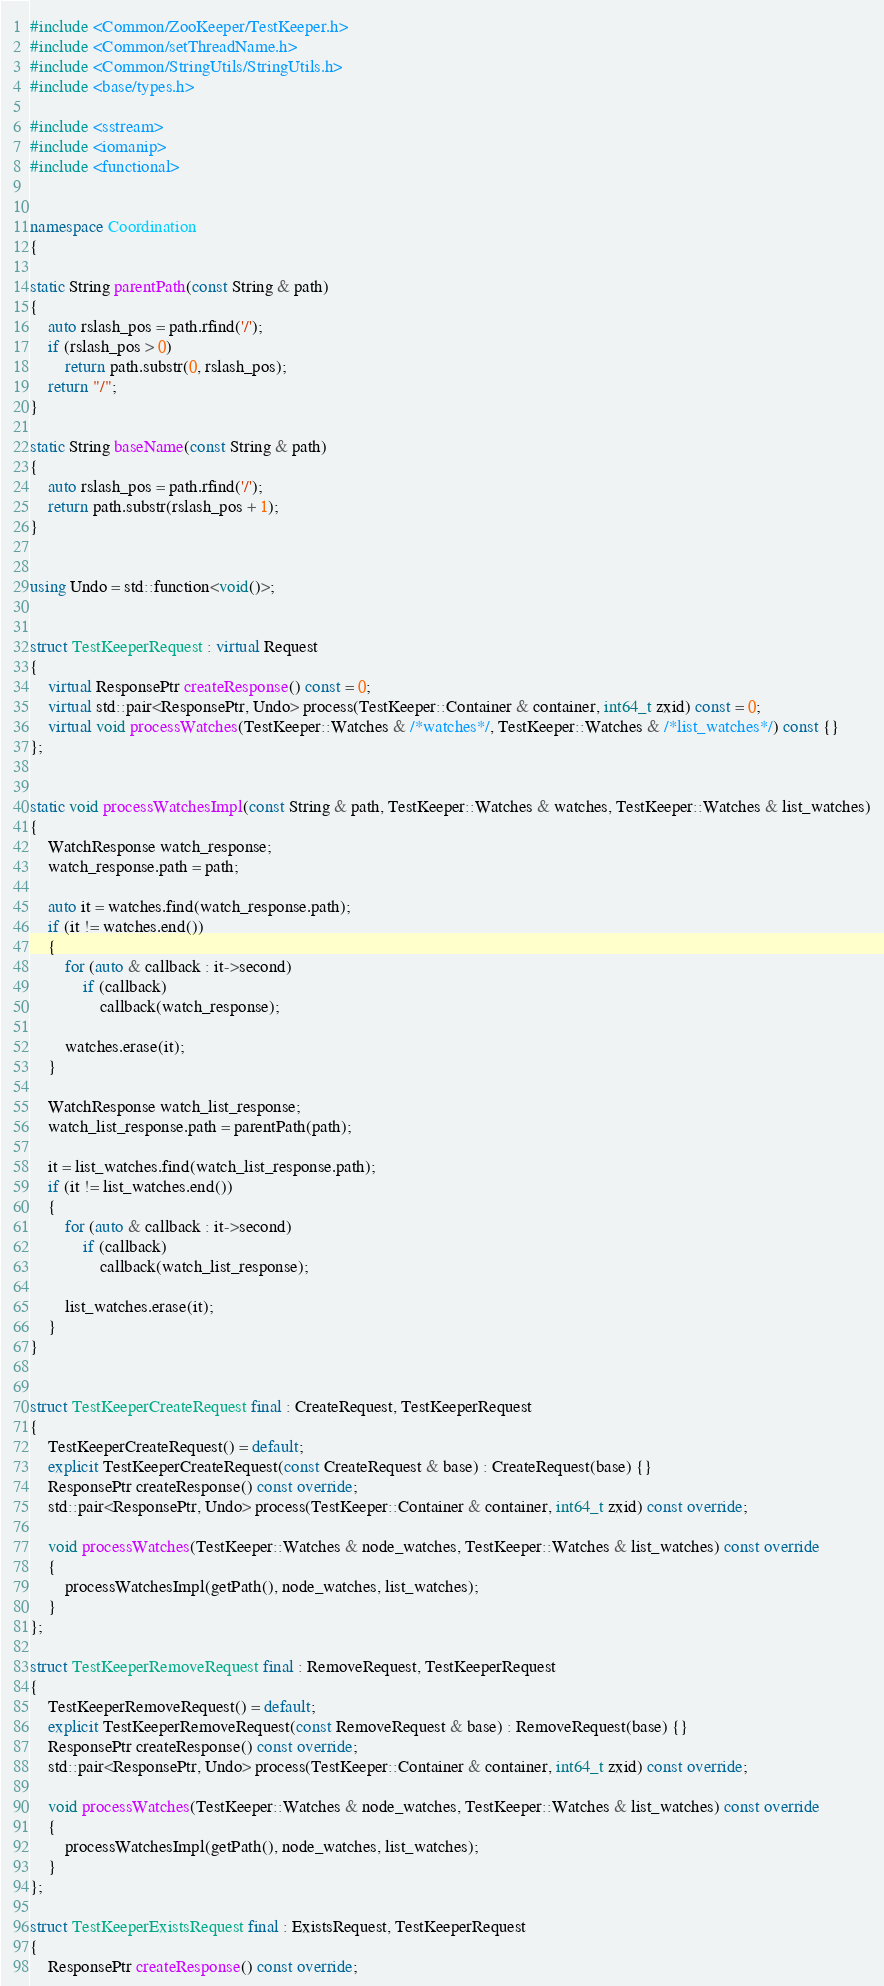<code> <loc_0><loc_0><loc_500><loc_500><_C++_>#include <Common/ZooKeeper/TestKeeper.h>
#include <Common/setThreadName.h>
#include <Common/StringUtils/StringUtils.h>
#include <base/types.h>

#include <sstream>
#include <iomanip>
#include <functional>


namespace Coordination
{

static String parentPath(const String & path)
{
    auto rslash_pos = path.rfind('/');
    if (rslash_pos > 0)
        return path.substr(0, rslash_pos);
    return "/";
}

static String baseName(const String & path)
{
    auto rslash_pos = path.rfind('/');
    return path.substr(rslash_pos + 1);
}


using Undo = std::function<void()>;


struct TestKeeperRequest : virtual Request
{
    virtual ResponsePtr createResponse() const = 0;
    virtual std::pair<ResponsePtr, Undo> process(TestKeeper::Container & container, int64_t zxid) const = 0;
    virtual void processWatches(TestKeeper::Watches & /*watches*/, TestKeeper::Watches & /*list_watches*/) const {}
};


static void processWatchesImpl(const String & path, TestKeeper::Watches & watches, TestKeeper::Watches & list_watches)
{
    WatchResponse watch_response;
    watch_response.path = path;

    auto it = watches.find(watch_response.path);
    if (it != watches.end())
    {
        for (auto & callback : it->second)
            if (callback)
                callback(watch_response);

        watches.erase(it);
    }

    WatchResponse watch_list_response;
    watch_list_response.path = parentPath(path);

    it = list_watches.find(watch_list_response.path);
    if (it != list_watches.end())
    {
        for (auto & callback : it->second)
            if (callback)
                callback(watch_list_response);

        list_watches.erase(it);
    }
}


struct TestKeeperCreateRequest final : CreateRequest, TestKeeperRequest
{
    TestKeeperCreateRequest() = default;
    explicit TestKeeperCreateRequest(const CreateRequest & base) : CreateRequest(base) {}
    ResponsePtr createResponse() const override;
    std::pair<ResponsePtr, Undo> process(TestKeeper::Container & container, int64_t zxid) const override;

    void processWatches(TestKeeper::Watches & node_watches, TestKeeper::Watches & list_watches) const override
    {
        processWatchesImpl(getPath(), node_watches, list_watches);
    }
};

struct TestKeeperRemoveRequest final : RemoveRequest, TestKeeperRequest
{
    TestKeeperRemoveRequest() = default;
    explicit TestKeeperRemoveRequest(const RemoveRequest & base) : RemoveRequest(base) {}
    ResponsePtr createResponse() const override;
    std::pair<ResponsePtr, Undo> process(TestKeeper::Container & container, int64_t zxid) const override;

    void processWatches(TestKeeper::Watches & node_watches, TestKeeper::Watches & list_watches) const override
    {
        processWatchesImpl(getPath(), node_watches, list_watches);
    }
};

struct TestKeeperExistsRequest final : ExistsRequest, TestKeeperRequest
{
    ResponsePtr createResponse() const override;</code> 